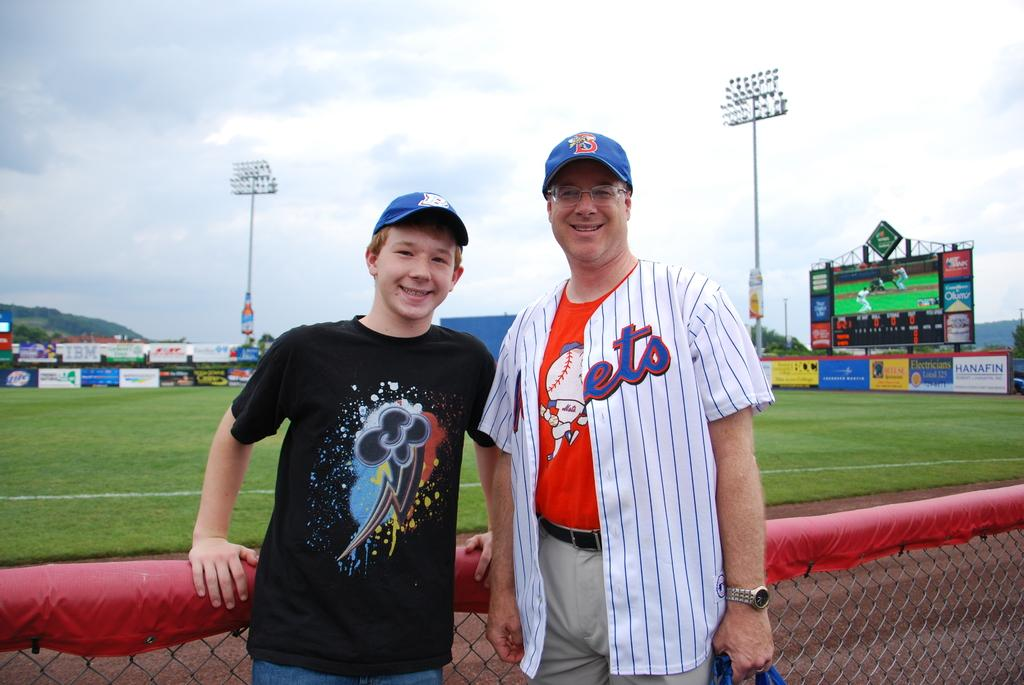Provide a one-sentence caption for the provided image. A man with the letters "ets" on his shirt and a boy infront of a baseball field. 